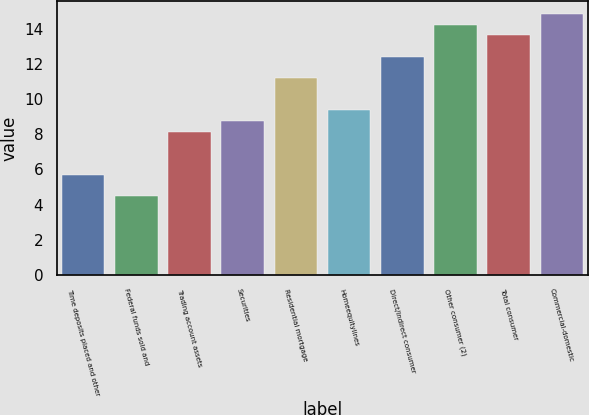<chart> <loc_0><loc_0><loc_500><loc_500><bar_chart><fcel>Time deposits placed and other<fcel>Federal funds sold and<fcel>Trading account assets<fcel>Securities<fcel>Residential mortgage<fcel>Homeequitylines<fcel>Direct/Indirect consumer<fcel>Other consumer (2)<fcel>Total consumer<fcel>Commercial-domestic<nl><fcel>5.71<fcel>4.49<fcel>8.15<fcel>8.76<fcel>11.2<fcel>9.37<fcel>12.42<fcel>14.25<fcel>13.64<fcel>14.86<nl></chart> 